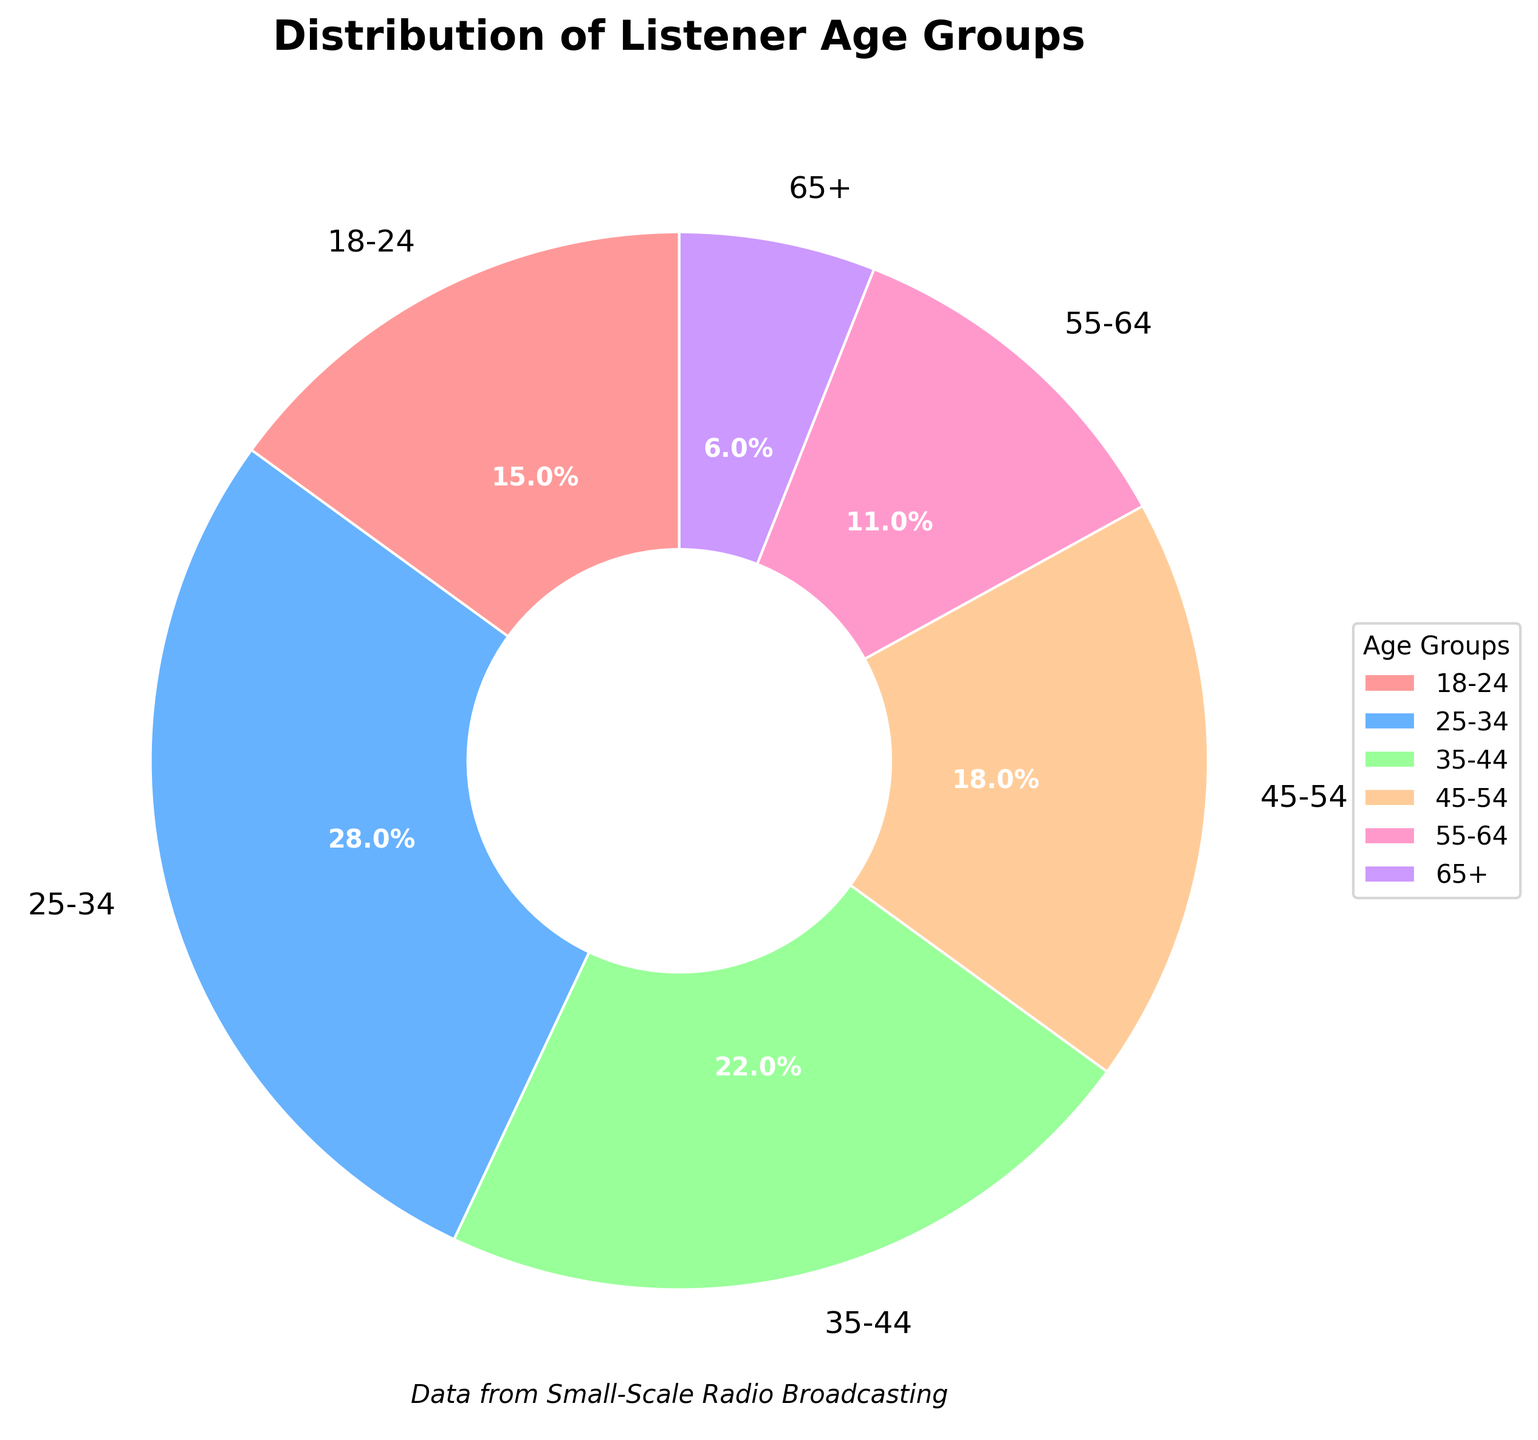Which age group has the highest percentage of listeners? Look at the pie chart and identify the age group with the largest slice. The percentage is also labeled.
Answer: 25-34 Which age group has the smallest percentage of listeners? Look at the pie chart and find the age group with the smallest slice. The percentage is also labeled.
Answer: 65+ What is the combined percentage of listeners aged 18-34? Sum the percentages of the 18-24 and 25-34 age groups: 15% + 28% = 43%
Answer: 43% How much more percentage of listeners are there in the 35-44 age group compared to the 65+ age group? Subtract the percentage of the 65+ age group from the 35-44 age group: 22% - 6% = 16%
Answer: 16% Which age group is represented by the pinkish color in the chart? Find the wedge that is colored pinkish and read the corresponding label.
Answer: 18-24 What is the difference in percentage between listeners aged 45-54 and those aged 55-64? Subtract the percentage of the 55-64 age group from the 45-54 age group: 18% - 11% = 7%
Answer: 7% What is the average percentage of listeners in the three oldest age groups (45-54, 55-64, 65+)? Sum the percentages and then divide by three: (18% + 11% + 6%) / 3 = 11.67%
Answer: 11.67% How many age groups have a percentage of listeners greater than or equal to 20%? Count the number of age groups where the percentage is 20% or higher. The relevant groups are 25-34 (28%) and 35-44 (22%).
Answer: 2 If you combine the percentage of listeners aged under 45, what fraction of the total do they represent? Add percentages of the relevant age groups (18-24: 15%, 25-34: 28%, 35-44: 22%) and convert to fraction: (15% + 28% + 22%) = 65%; 65% is 0.65 of the total
Answer: 0.65 Is the percentage of listeners in the 25-34 age group more than double that of the 55-64 age group? Compare the percentage of the 25-34 age group (28%) with twice the percentage of the 55-64 age group (11% * 2 = 22%): 28% > 22%
Answer: Yes 